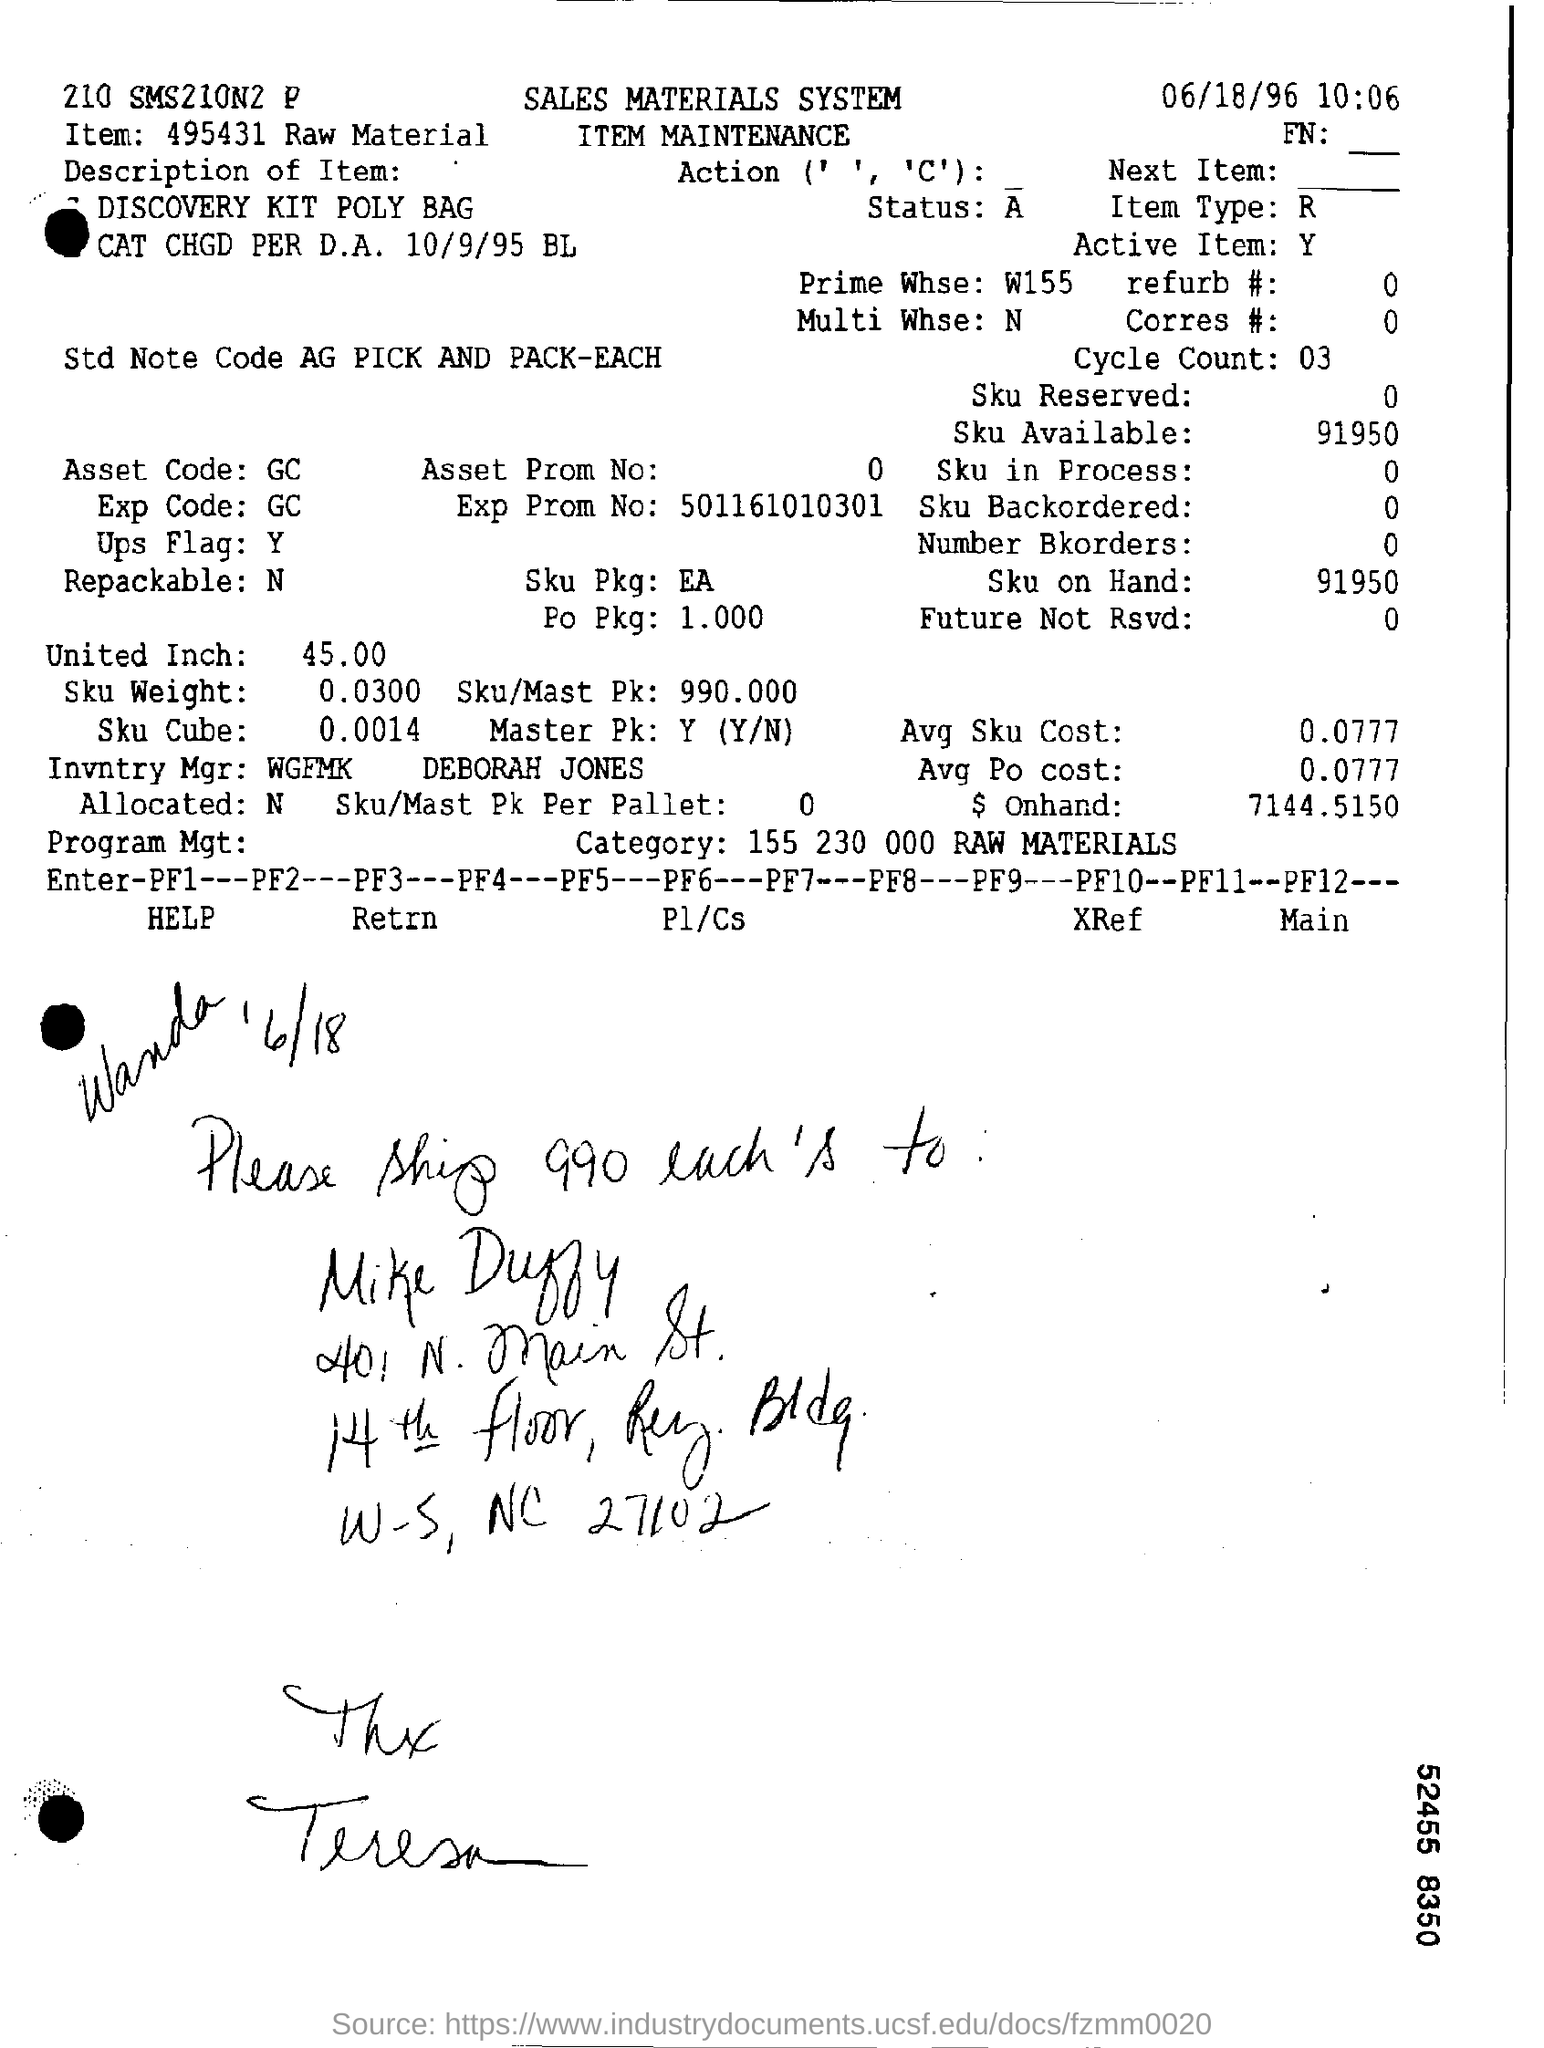Draw attention to some important aspects in this diagram. What is the type of item being referred to? The Prime Whse is W155.. The Sku/Mast Pk is 990,000. What is the amount currently on hand? It is 71,44.5150 and counting. What is the Asset code? It is a GC. 